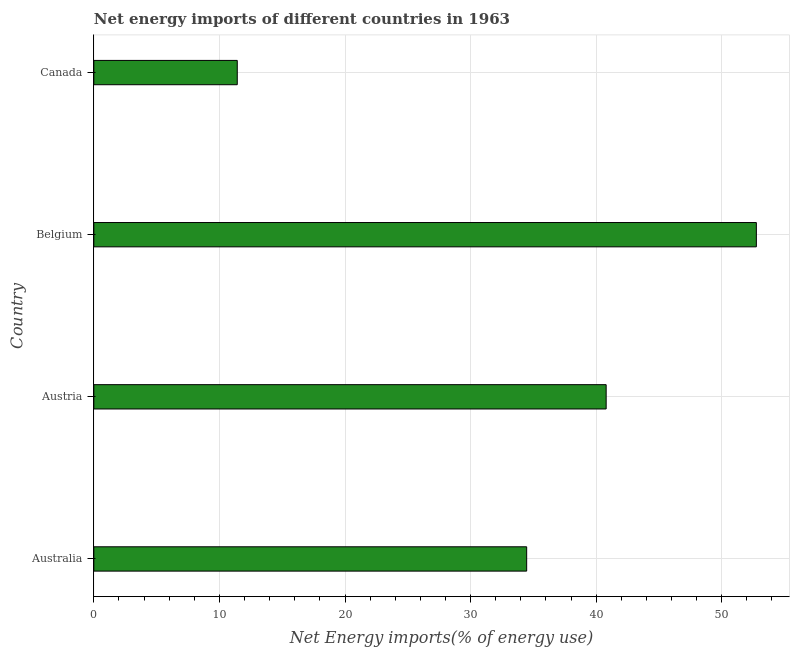Does the graph contain any zero values?
Provide a short and direct response. No. Does the graph contain grids?
Make the answer very short. Yes. What is the title of the graph?
Give a very brief answer. Net energy imports of different countries in 1963. What is the label or title of the X-axis?
Make the answer very short. Net Energy imports(% of energy use). What is the label or title of the Y-axis?
Make the answer very short. Country. What is the energy imports in Australia?
Offer a terse response. 34.47. Across all countries, what is the maximum energy imports?
Make the answer very short. 52.76. Across all countries, what is the minimum energy imports?
Offer a very short reply. 11.42. In which country was the energy imports maximum?
Ensure brevity in your answer.  Belgium. What is the sum of the energy imports?
Keep it short and to the point. 139.44. What is the difference between the energy imports in Australia and Austria?
Make the answer very short. -6.33. What is the average energy imports per country?
Your response must be concise. 34.86. What is the median energy imports?
Offer a terse response. 37.63. What is the ratio of the energy imports in Belgium to that in Canada?
Your response must be concise. 4.62. Is the difference between the energy imports in Australia and Canada greater than the difference between any two countries?
Offer a very short reply. No. What is the difference between the highest and the second highest energy imports?
Give a very brief answer. 11.96. What is the difference between the highest and the lowest energy imports?
Your response must be concise. 41.33. In how many countries, is the energy imports greater than the average energy imports taken over all countries?
Provide a succinct answer. 2. How many bars are there?
Your answer should be very brief. 4. How many countries are there in the graph?
Offer a terse response. 4. What is the difference between two consecutive major ticks on the X-axis?
Offer a terse response. 10. What is the Net Energy imports(% of energy use) in Australia?
Your answer should be compact. 34.47. What is the Net Energy imports(% of energy use) in Austria?
Ensure brevity in your answer.  40.8. What is the Net Energy imports(% of energy use) in Belgium?
Provide a short and direct response. 52.76. What is the Net Energy imports(% of energy use) of Canada?
Your answer should be compact. 11.42. What is the difference between the Net Energy imports(% of energy use) in Australia and Austria?
Offer a terse response. -6.33. What is the difference between the Net Energy imports(% of energy use) in Australia and Belgium?
Provide a succinct answer. -18.29. What is the difference between the Net Energy imports(% of energy use) in Australia and Canada?
Make the answer very short. 23.04. What is the difference between the Net Energy imports(% of energy use) in Austria and Belgium?
Keep it short and to the point. -11.96. What is the difference between the Net Energy imports(% of energy use) in Austria and Canada?
Your response must be concise. 29.37. What is the difference between the Net Energy imports(% of energy use) in Belgium and Canada?
Offer a very short reply. 41.33. What is the ratio of the Net Energy imports(% of energy use) in Australia to that in Austria?
Provide a succinct answer. 0.84. What is the ratio of the Net Energy imports(% of energy use) in Australia to that in Belgium?
Keep it short and to the point. 0.65. What is the ratio of the Net Energy imports(% of energy use) in Australia to that in Canada?
Offer a terse response. 3.02. What is the ratio of the Net Energy imports(% of energy use) in Austria to that in Belgium?
Keep it short and to the point. 0.77. What is the ratio of the Net Energy imports(% of energy use) in Austria to that in Canada?
Provide a short and direct response. 3.57. What is the ratio of the Net Energy imports(% of energy use) in Belgium to that in Canada?
Your answer should be very brief. 4.62. 